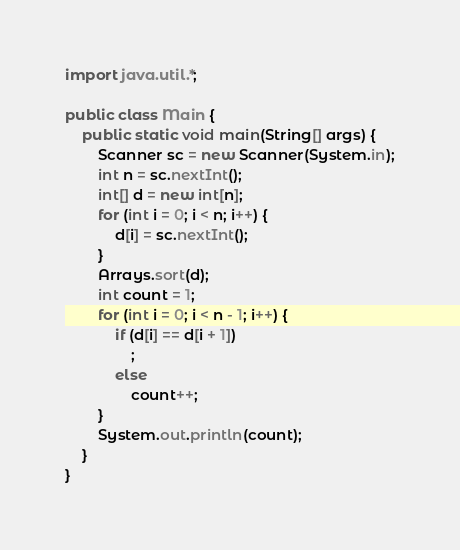<code> <loc_0><loc_0><loc_500><loc_500><_Java_>import java.util.*;

public class Main {
    public static void main(String[] args) {
        Scanner sc = new Scanner(System.in);
        int n = sc.nextInt();
        int[] d = new int[n];
        for (int i = 0; i < n; i++) {
            d[i] = sc.nextInt();
        }
        Arrays.sort(d);
        int count = 1;
        for (int i = 0; i < n - 1; i++) {
            if (d[i] == d[i + 1])
                ;
            else
                count++;
        }
        System.out.println(count);
    }
}</code> 